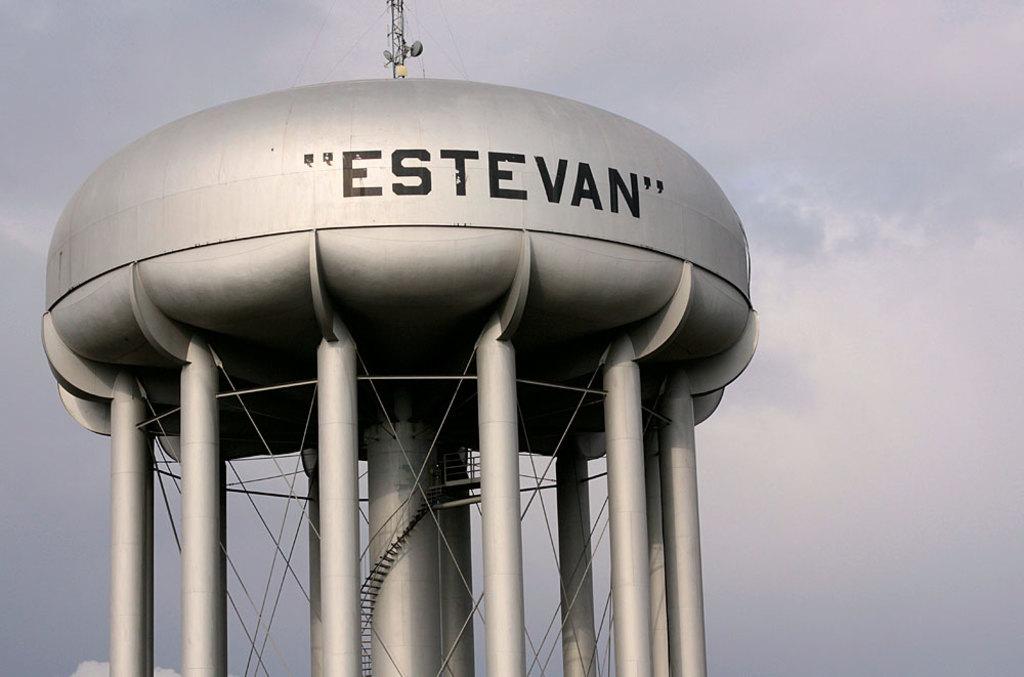What does the water tower say?
Provide a short and direct response. Estevan. 